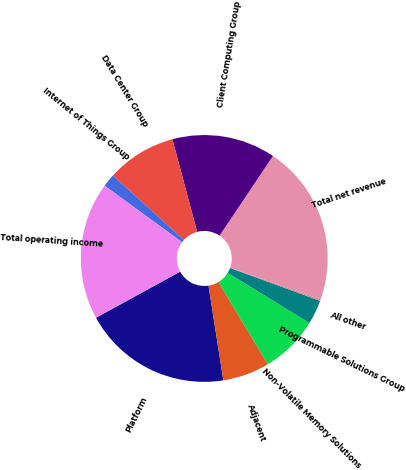Convert chart to OTSL. <chart><loc_0><loc_0><loc_500><loc_500><pie_chart><fcel>Platform<fcel>Adjacent<fcel>Non-Volatile Memory Solutions<fcel>Programmable Solutions Group<fcel>All other<fcel>Total net revenue<fcel>Client Computing Group<fcel>Data Center Group<fcel>Internet of Things Group<fcel>Total operating income<nl><fcel>19.5%<fcel>6.14%<fcel>7.63%<fcel>3.17%<fcel>0.21%<fcel>20.98%<fcel>13.56%<fcel>9.11%<fcel>1.69%<fcel>18.01%<nl></chart> 